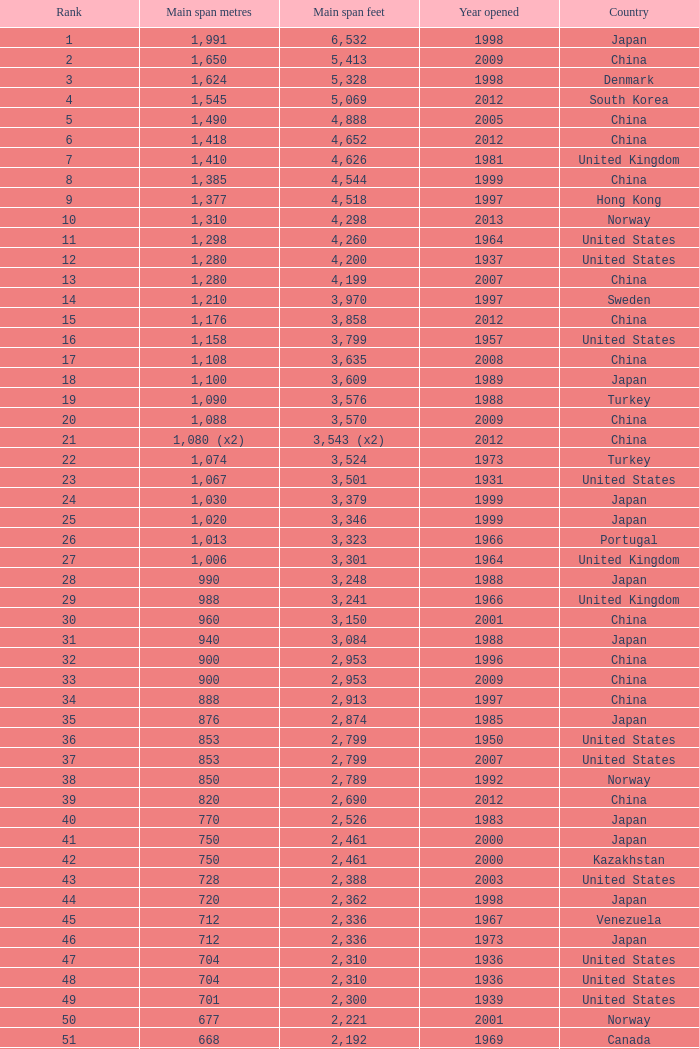What is the highest rank from the year greater than 2010 with 430 main span metres? 94.0. 